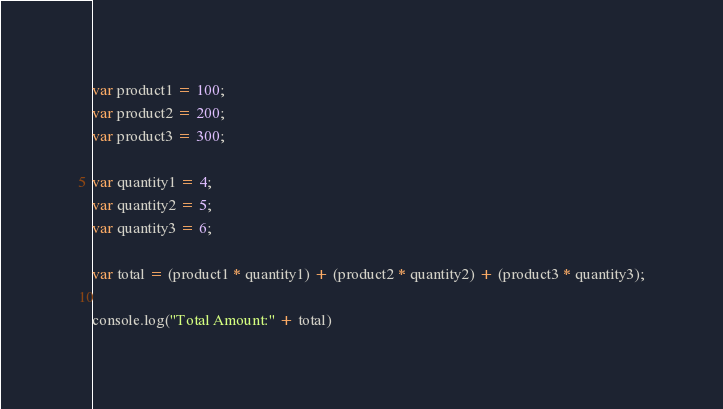Convert code to text. <code><loc_0><loc_0><loc_500><loc_500><_JavaScript_>var product1 = 100;
var product2 = 200;
var product3 = 300;

var quantity1 = 4;
var quantity2 = 5;
var quantity3 = 6;

var total = (product1 * quantity1) + (product2 * quantity2) + (product3 * quantity3);

console.log("Total Amount:" + total)</code> 